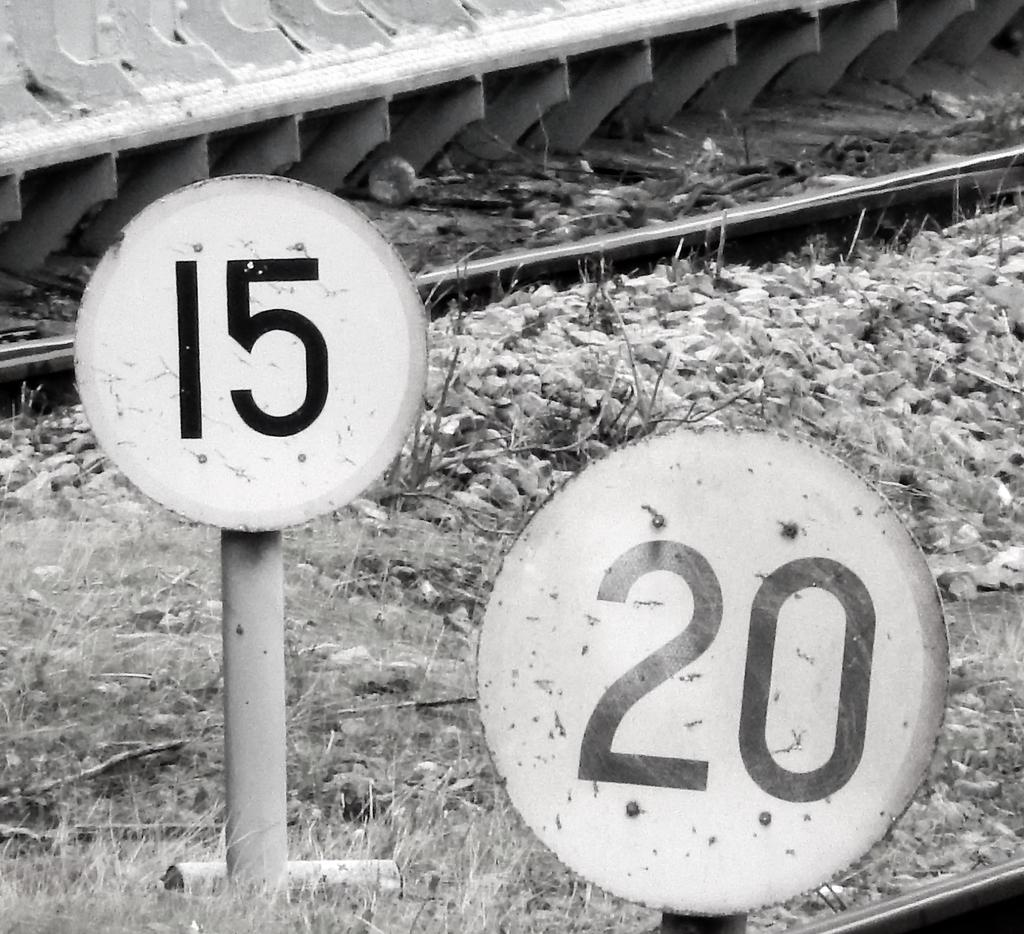Provide a one-sentence caption for the provided image. Two signs are in a grassy area that say 15 and 20. 